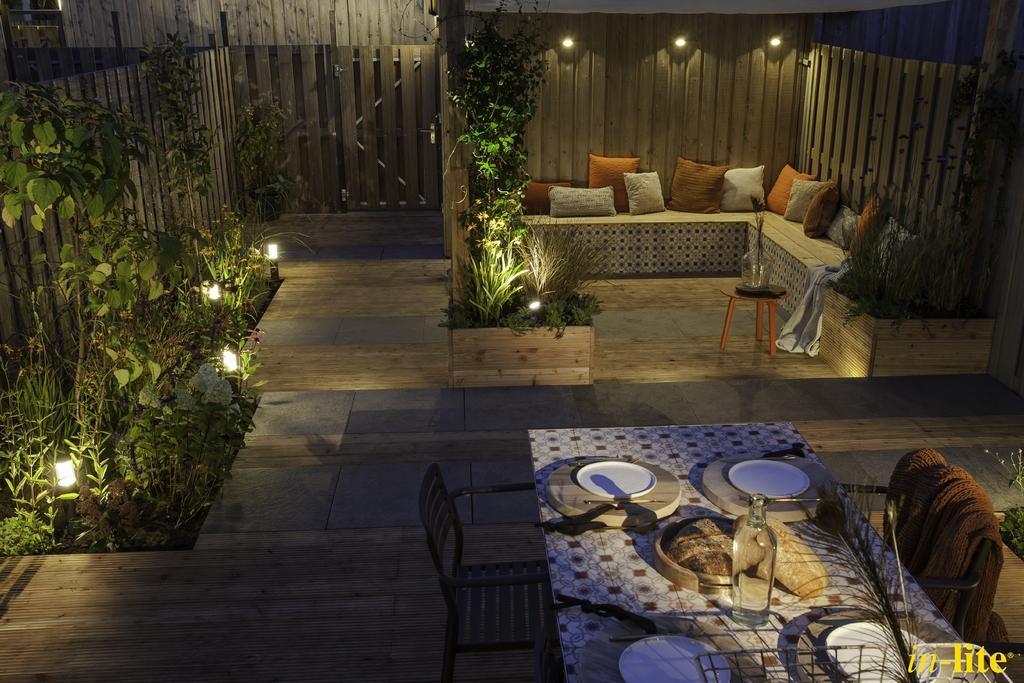Can you describe this image briefly? In this picture we can see a sofa with colourful cushions. Here we can see plants. These are lights. This is a floor, stool and a flower vase on it. We can see planets, bottle. These are chairs. We can see a brown colour towel on a chair. 